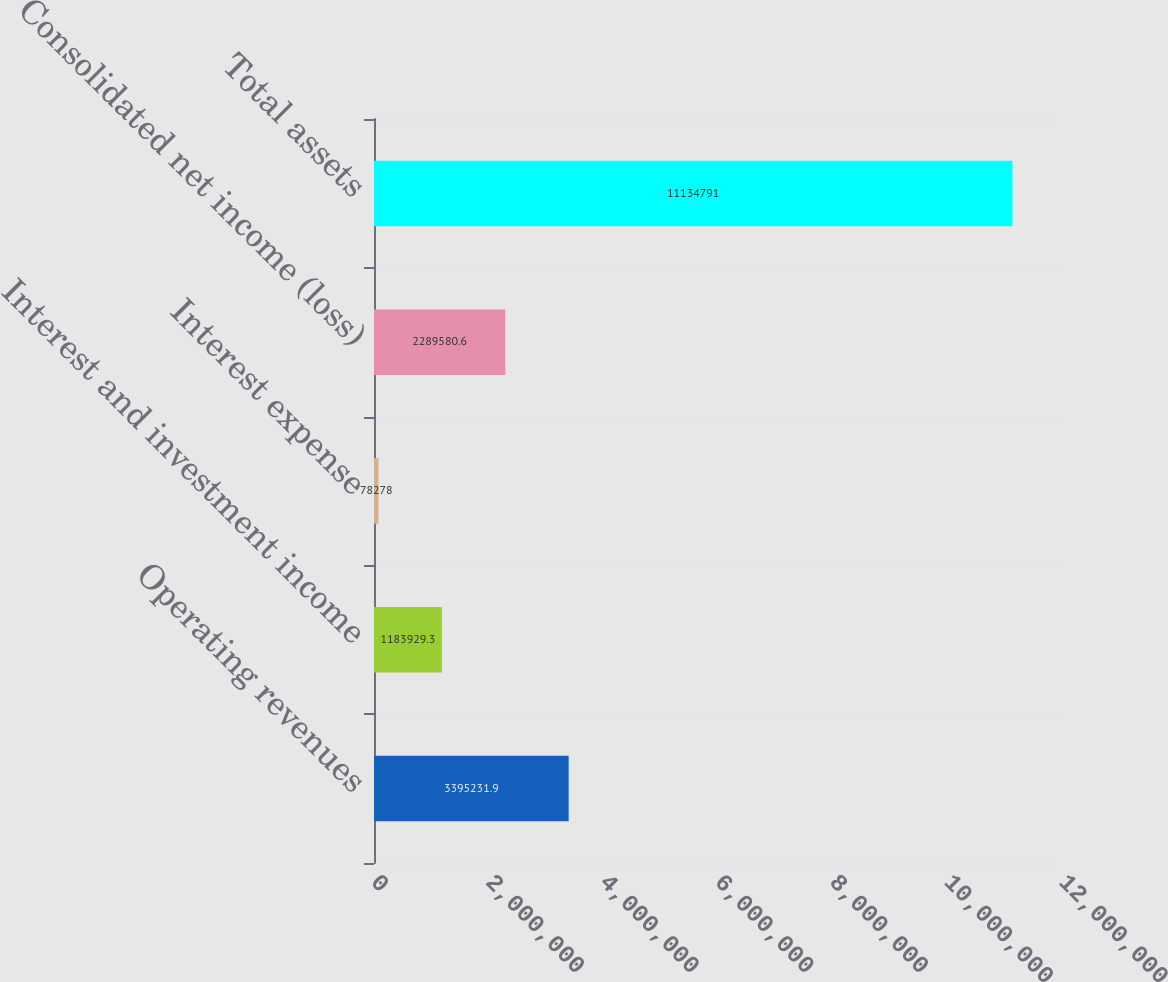<chart> <loc_0><loc_0><loc_500><loc_500><bar_chart><fcel>Operating revenues<fcel>Interest and investment income<fcel>Interest expense<fcel>Consolidated net income (loss)<fcel>Total assets<nl><fcel>3.39523e+06<fcel>1.18393e+06<fcel>78278<fcel>2.28958e+06<fcel>1.11348e+07<nl></chart> 